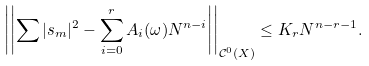Convert formula to latex. <formula><loc_0><loc_0><loc_500><loc_500>\left | \left | \sum | s _ { m } | ^ { 2 } - \sum _ { i = 0 } ^ { r } A _ { i } ( \omega ) N ^ { n - i } \right | \right | _ { \mathcal { C } ^ { 0 } ( X ) } \leq K _ { r } N ^ { n - r - 1 } .</formula> 